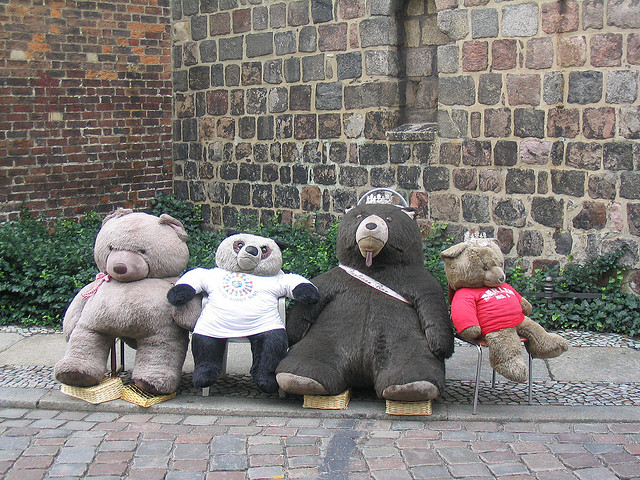<image>What does the large dark teddy bear represent? I don't know what the large dark teddy bear represents. It could represent a 'king', 'papa bear', or 'beauty queen'. What does the large dark teddy bear represent? I don't know what the large dark teddy bear represents. It can be seen as 'king', 'papa bear', 'beauty queen', 'russia', 'daddy bear', or 'queen'. 